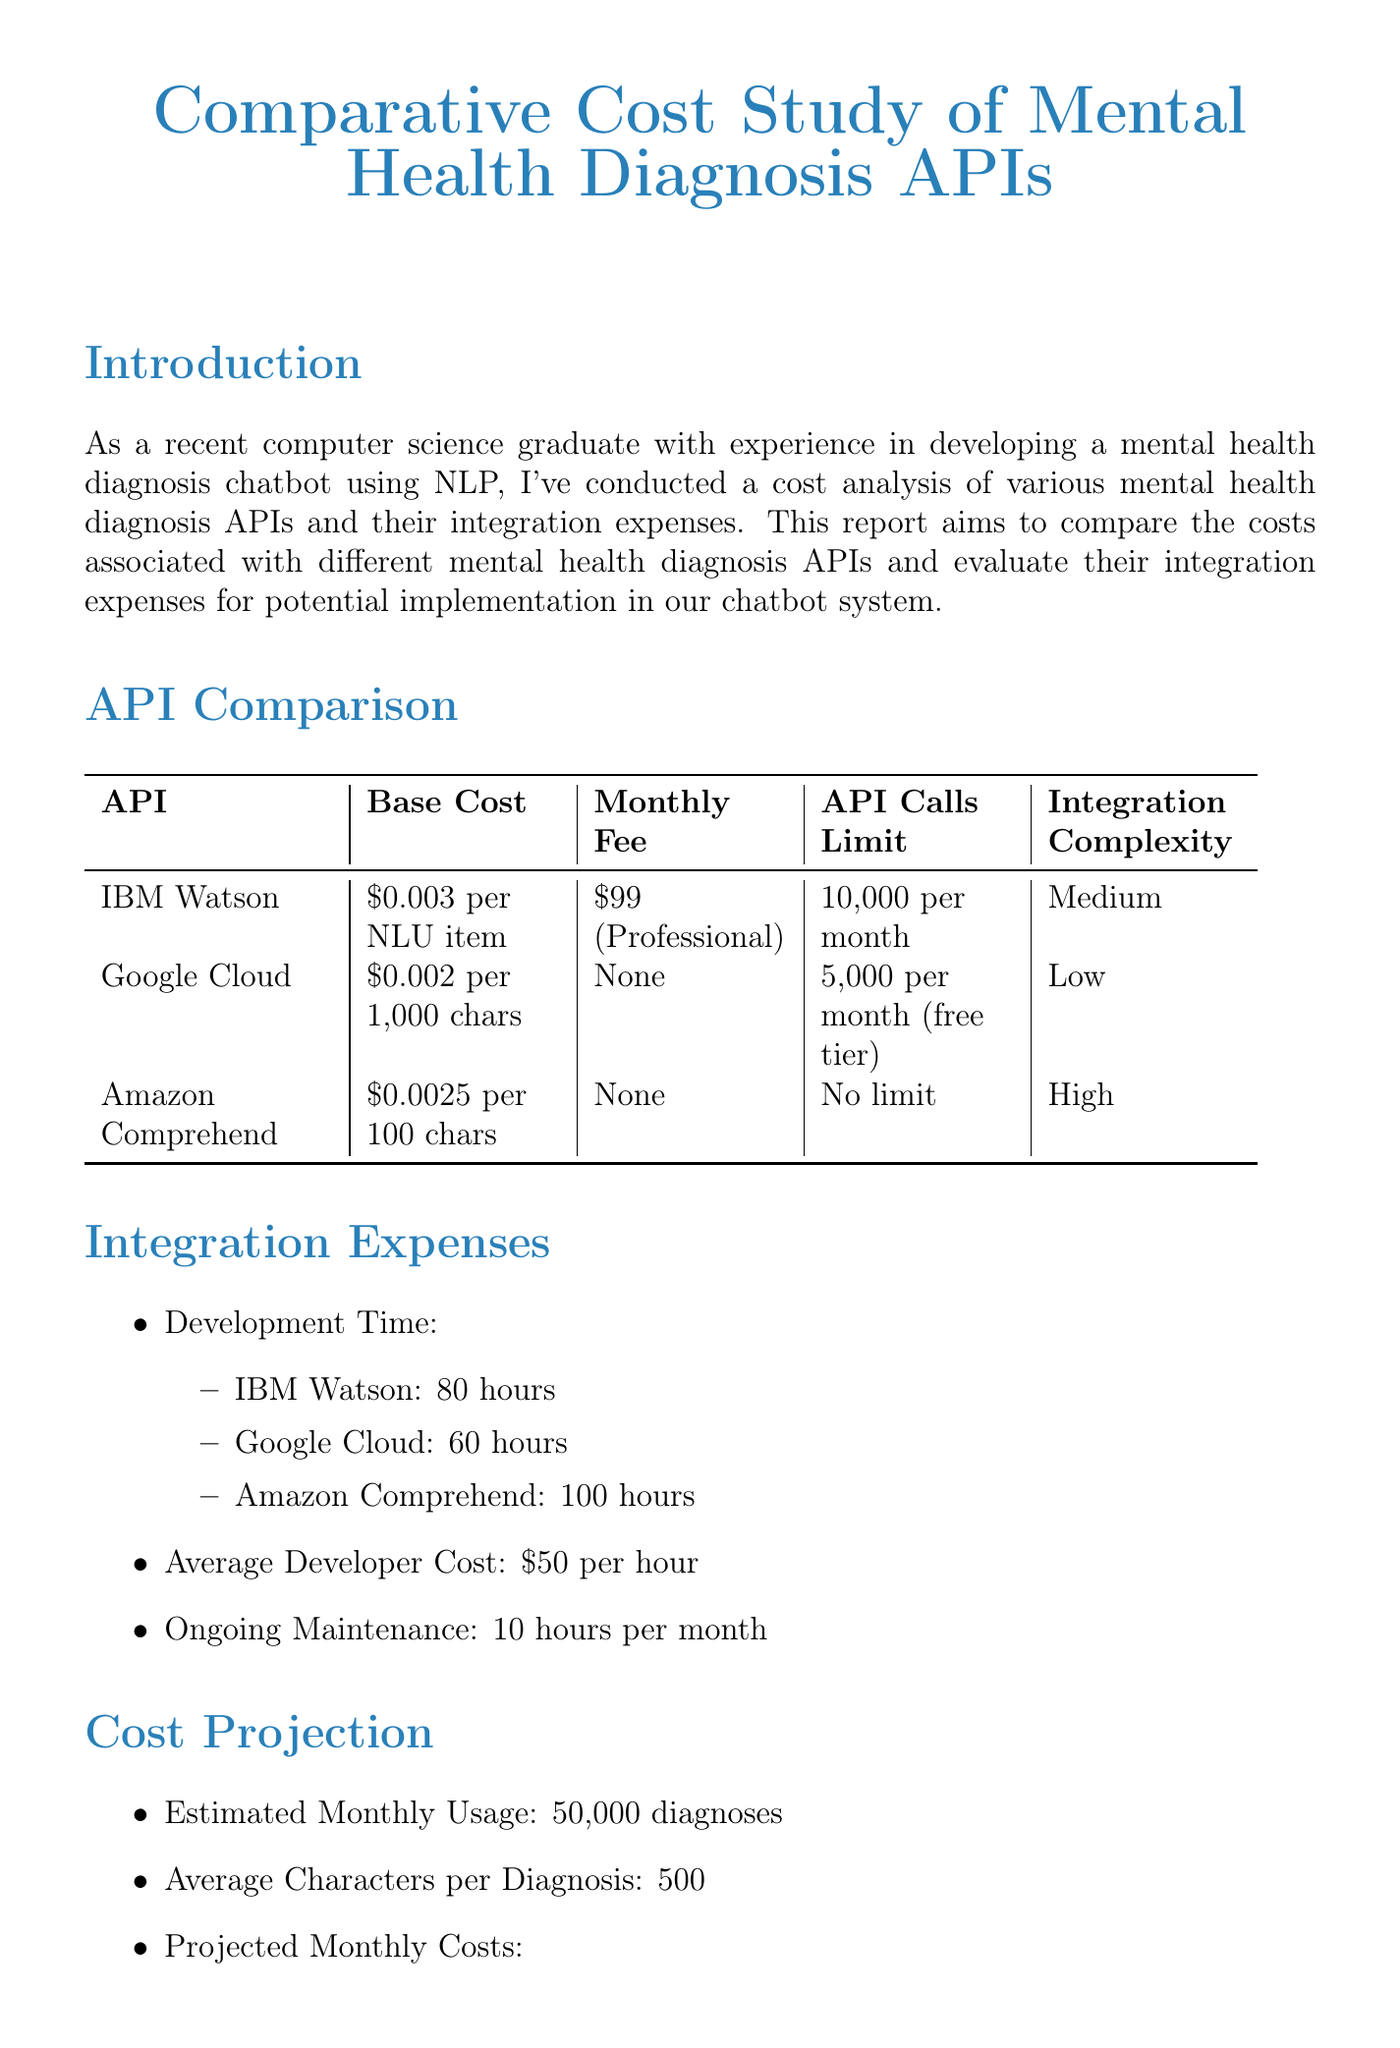What is the title of the report? The title of the report is provided at the beginning and states its focus on cost comparison.
Answer: Comparative Cost Study of Mental Health Diagnosis APIs and Integration Expenses What is the integration complexity of IBM Watson? The document lists integration complexity for each API, providing specific assessments for IBM Watson.
Answer: Medium How much is the average developer cost per hour? The average developer cost is explicitly stated in the integration expenses section of the document.
Answer: $50 per hour What is the monthly fee for the Google Cloud Natural Language API? The document provides specific details about the monthly fees for each API and notes that Google Cloud has no fixed monthly fee.
Answer: None Which API has the highest projected monthly cost? By comparing the projected costs listed in the cost projection section, we can identify which API is the most expensive.
Answer: Amazon Comprehend What is the estimated monthly API usage in diagnoses? The document provides an estimate of the monthly API usage based on usage calculations presented within the cost projection section.
Answer: 50,000 diagnoses Which API is recommended for implementation in the conclusion? The recommendation is made in the conclusion section, summarizing the evaluation of each API in the report.
Answer: Google Cloud Natural Language API What is the development time for Amazon Comprehend? The document lists the development time for each API under integration expenses, specifying the time required for Amazon Comprehend.
Answer: 100 hours 